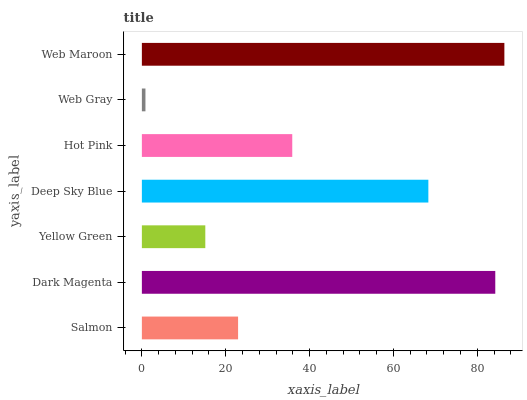Is Web Gray the minimum?
Answer yes or no. Yes. Is Web Maroon the maximum?
Answer yes or no. Yes. Is Dark Magenta the minimum?
Answer yes or no. No. Is Dark Magenta the maximum?
Answer yes or no. No. Is Dark Magenta greater than Salmon?
Answer yes or no. Yes. Is Salmon less than Dark Magenta?
Answer yes or no. Yes. Is Salmon greater than Dark Magenta?
Answer yes or no. No. Is Dark Magenta less than Salmon?
Answer yes or no. No. Is Hot Pink the high median?
Answer yes or no. Yes. Is Hot Pink the low median?
Answer yes or no. Yes. Is Deep Sky Blue the high median?
Answer yes or no. No. Is Dark Magenta the low median?
Answer yes or no. No. 